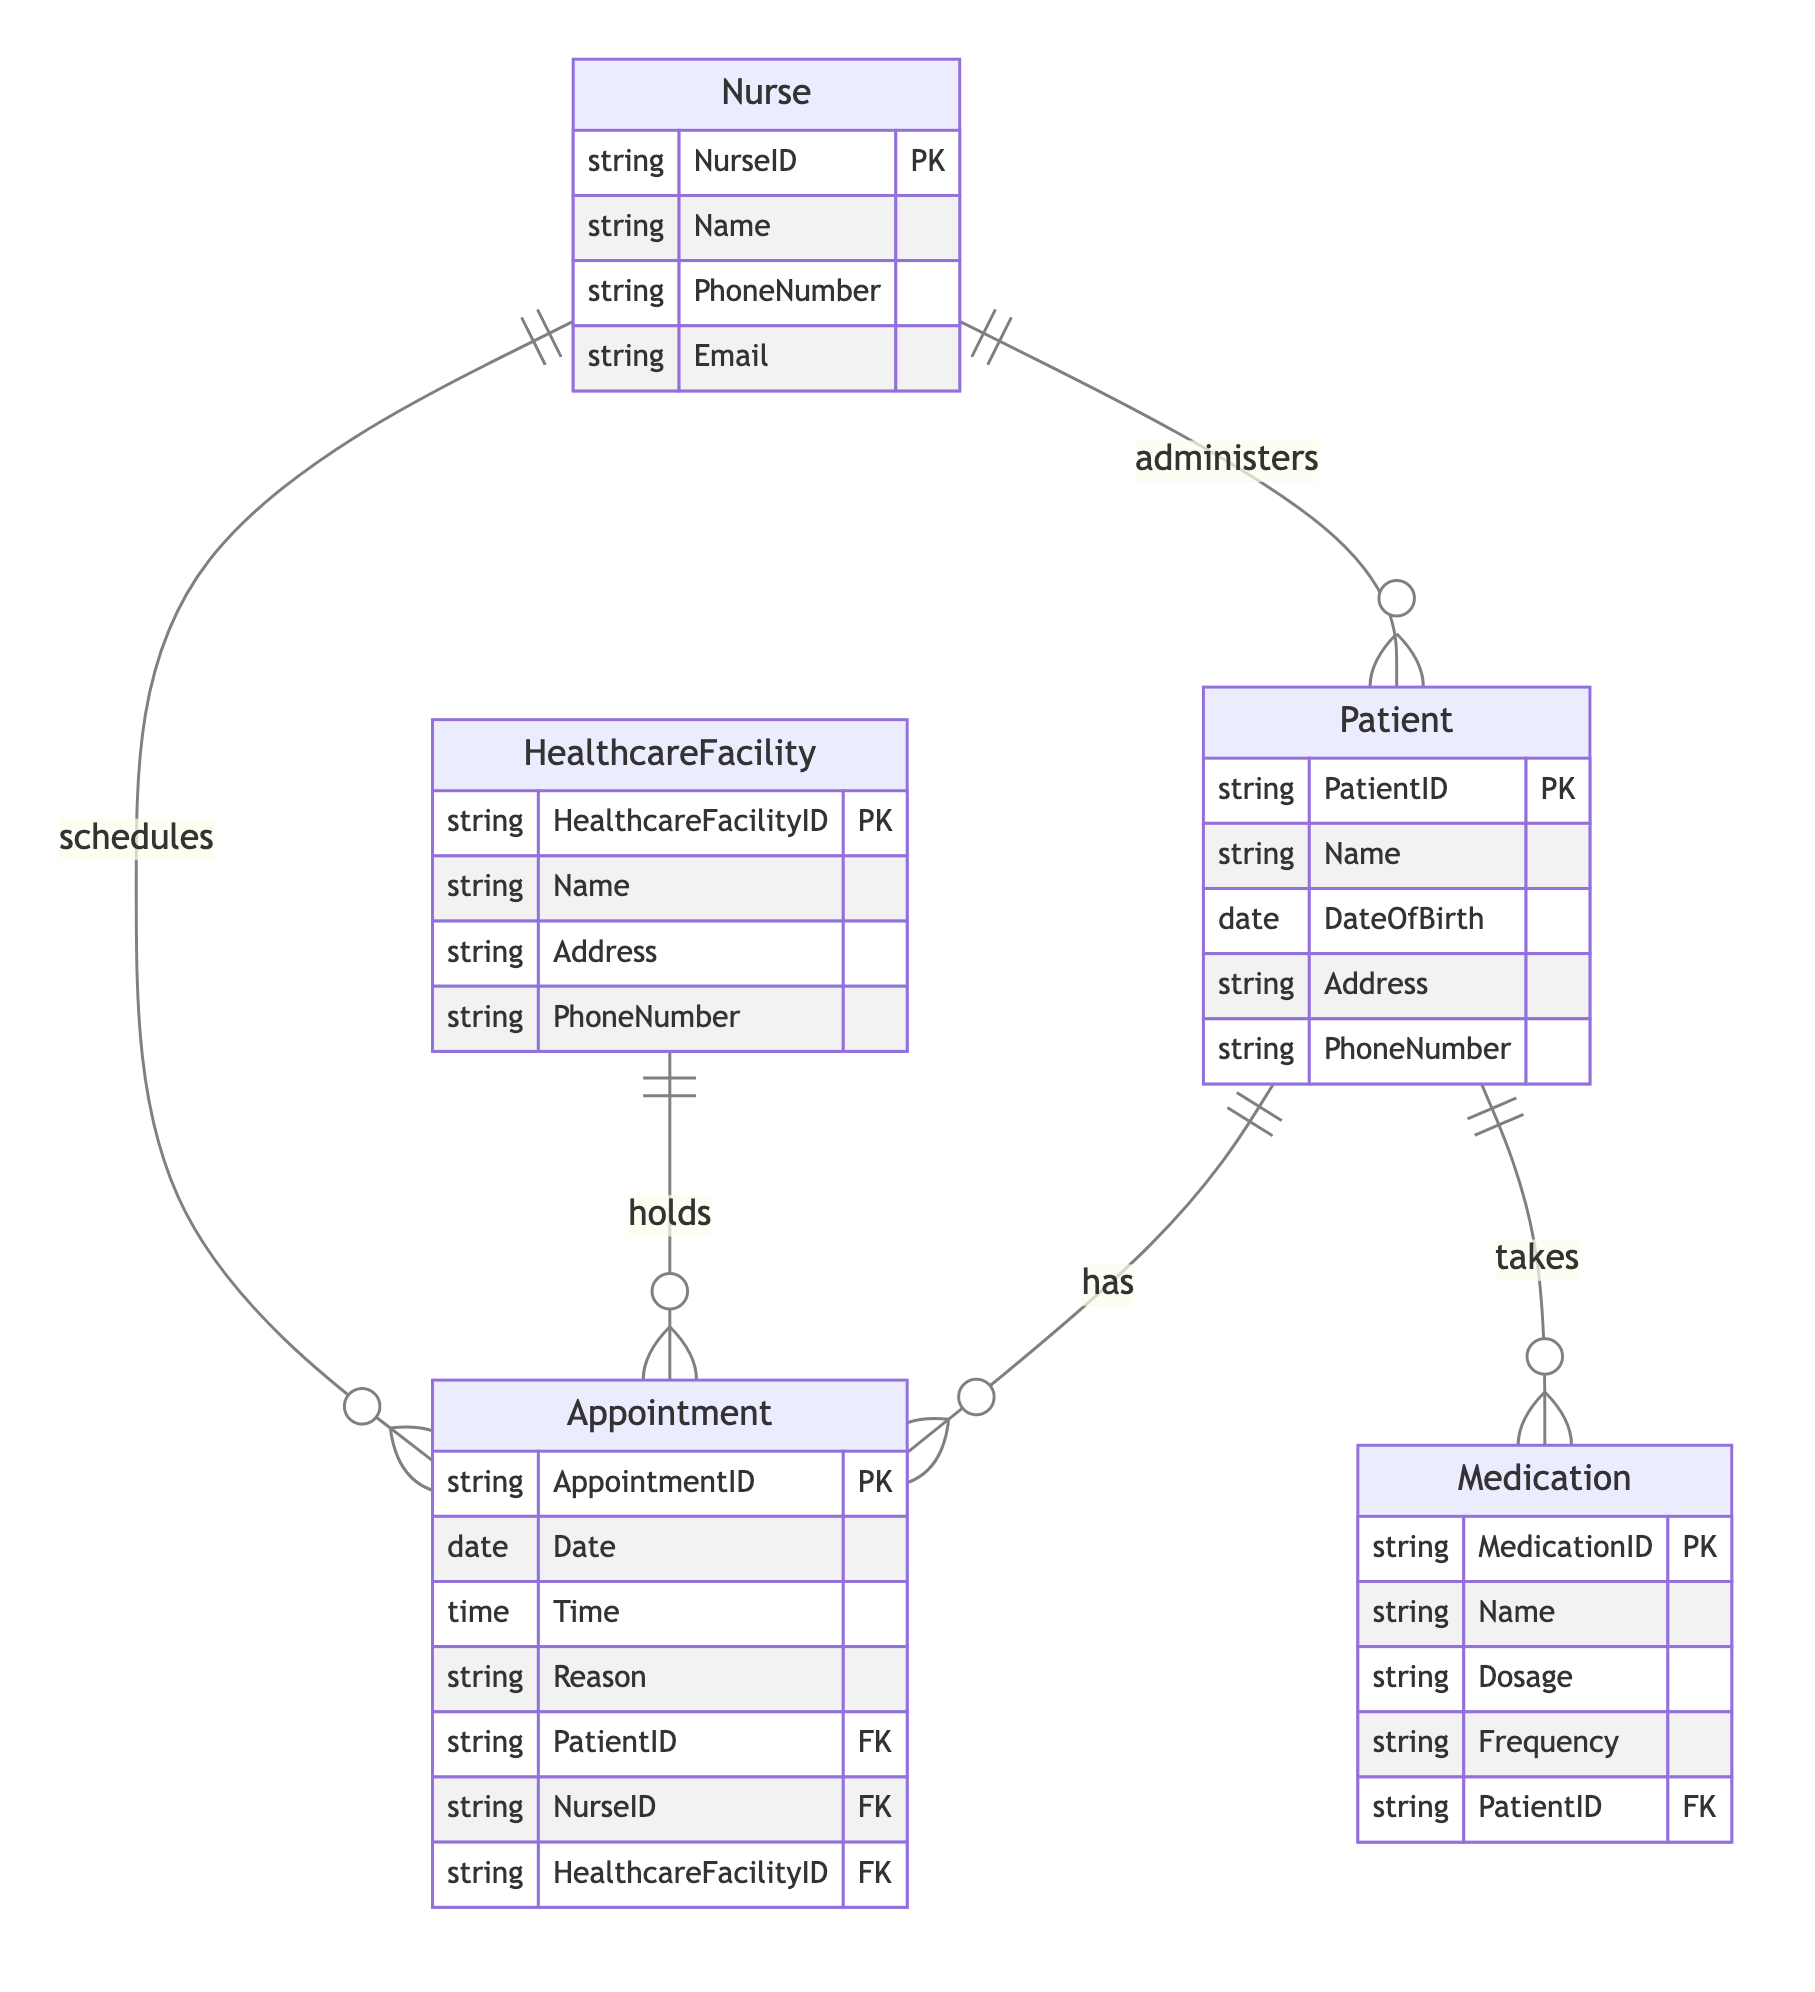What is the primary key for the Patient entity? The primary key for the Patient entity is PatientID, which is indicated as a unique identifier for each patient in the diagram.
Answer: PatientID How many attributes does the Nurse entity have? The Nurse entity has four attributes: NurseID, Name, PhoneNumber, and Email. This can be counted directly from the attributes listed under the Nurse entity in the diagram.
Answer: 4 What type of relationship exists between the Nurse and Appointment entities? The relationship between the Nurse and Appointment entities is "schedules", indicating that a Nurse can schedule many Appointments, which is a one-to-many relationship.
Answer: schedules Who administers care to the Patient? The Nurse administers care to the Patient, as indicated by the "administers" relationship between the Nurse and Patient entities.
Answer: Nurse How many medications can a Patient take? A Patient can take many Medications, as indicated by the "takes" relationship between the Patient and Medication entities, which is a one-to-many relationship.
Answer: many What is the relationship type between HealthcareFacility and Appointment? The relationship type between HealthcareFacility and Appointment is "holds", showing that one Healthcare Facility can hold many Appointments. This is again a one-to-many relationship.
Answer: holds How many entities are present in the diagram? The diagram includes five entities: Patient, Nurse, Appointment, HealthcareFacility, and Medication. You can count these entities directly from the list at the beginning of the diagram.
Answer: 5 Which entity is involved in scheduling appointments? The Nurse entity is involved in scheduling appointments. This is illustrated by the "schedules" relationship directed from Nurse to Appointment in the diagram.
Answer: Nurse What does the Patient take? The Patient takes Medication, as shown by the "takes" relationship from Patient to Medication in the diagram.
Answer: Medication 